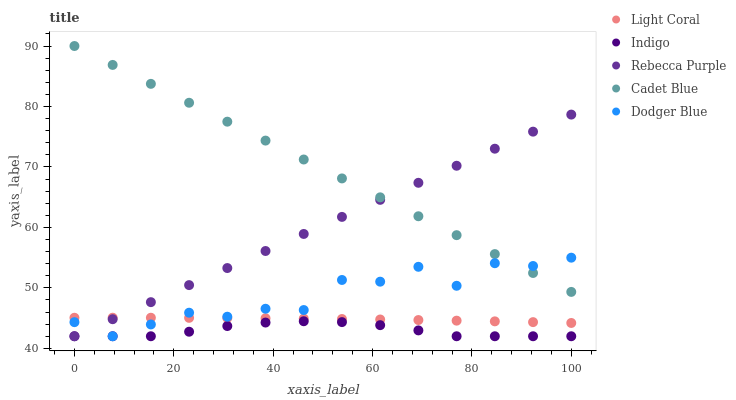Does Indigo have the minimum area under the curve?
Answer yes or no. Yes. Does Cadet Blue have the maximum area under the curve?
Answer yes or no. Yes. Does Dodger Blue have the minimum area under the curve?
Answer yes or no. No. Does Dodger Blue have the maximum area under the curve?
Answer yes or no. No. Is Cadet Blue the smoothest?
Answer yes or no. Yes. Is Dodger Blue the roughest?
Answer yes or no. Yes. Is Dodger Blue the smoothest?
Answer yes or no. No. Is Cadet Blue the roughest?
Answer yes or no. No. Does Dodger Blue have the lowest value?
Answer yes or no. Yes. Does Cadet Blue have the lowest value?
Answer yes or no. No. Does Cadet Blue have the highest value?
Answer yes or no. Yes. Does Dodger Blue have the highest value?
Answer yes or no. No. Is Light Coral less than Cadet Blue?
Answer yes or no. Yes. Is Cadet Blue greater than Indigo?
Answer yes or no. Yes. Does Rebecca Purple intersect Cadet Blue?
Answer yes or no. Yes. Is Rebecca Purple less than Cadet Blue?
Answer yes or no. No. Is Rebecca Purple greater than Cadet Blue?
Answer yes or no. No. Does Light Coral intersect Cadet Blue?
Answer yes or no. No. 